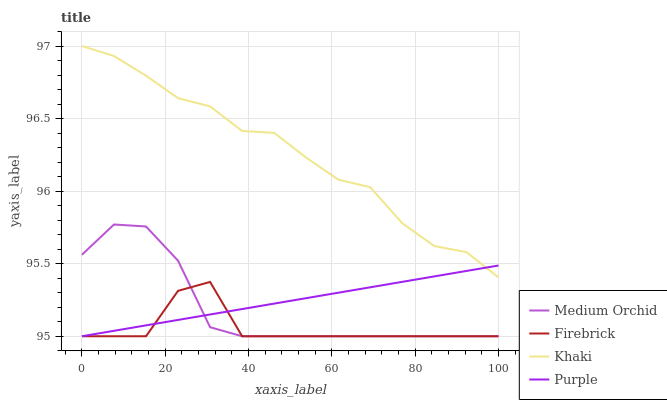Does Firebrick have the minimum area under the curve?
Answer yes or no. Yes. Does Khaki have the maximum area under the curve?
Answer yes or no. Yes. Does Medium Orchid have the minimum area under the curve?
Answer yes or no. No. Does Medium Orchid have the maximum area under the curve?
Answer yes or no. No. Is Purple the smoothest?
Answer yes or no. Yes. Is Firebrick the roughest?
Answer yes or no. Yes. Is Medium Orchid the smoothest?
Answer yes or no. No. Is Medium Orchid the roughest?
Answer yes or no. No. Does Purple have the lowest value?
Answer yes or no. Yes. Does Khaki have the lowest value?
Answer yes or no. No. Does Khaki have the highest value?
Answer yes or no. Yes. Does Medium Orchid have the highest value?
Answer yes or no. No. Is Medium Orchid less than Khaki?
Answer yes or no. Yes. Is Khaki greater than Medium Orchid?
Answer yes or no. Yes. Does Purple intersect Khaki?
Answer yes or no. Yes. Is Purple less than Khaki?
Answer yes or no. No. Is Purple greater than Khaki?
Answer yes or no. No. Does Medium Orchid intersect Khaki?
Answer yes or no. No. 